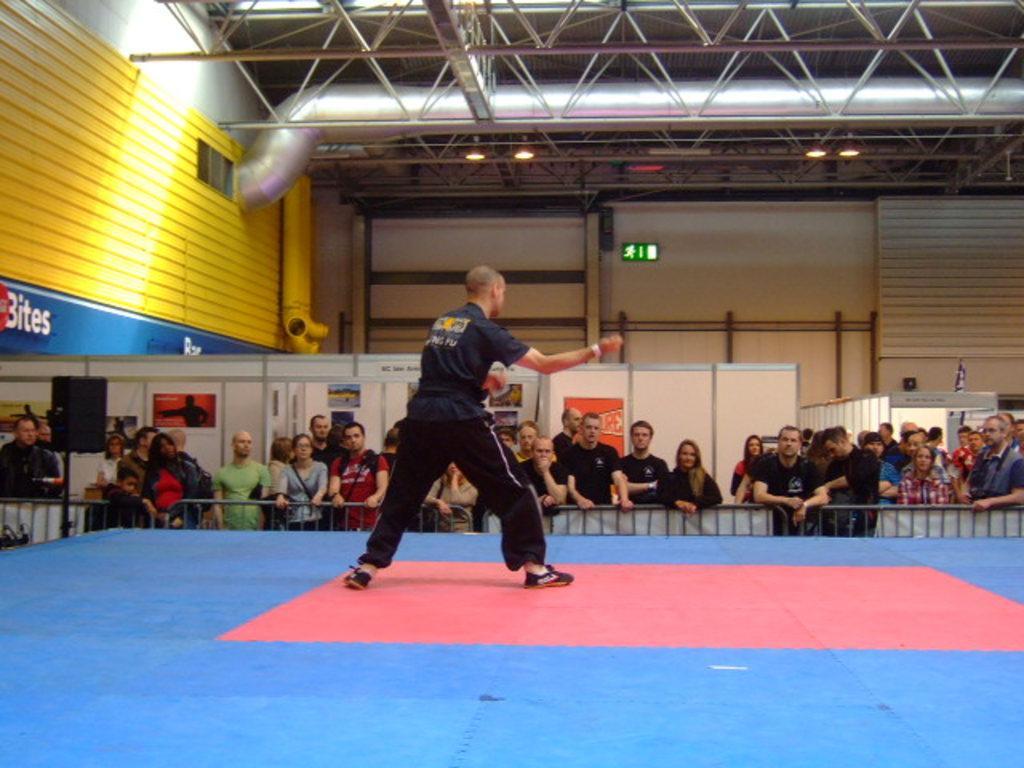Please provide a concise description of this image. In the image we can see there is a person standing on the stage and there are spectators watching the person on the stage. 